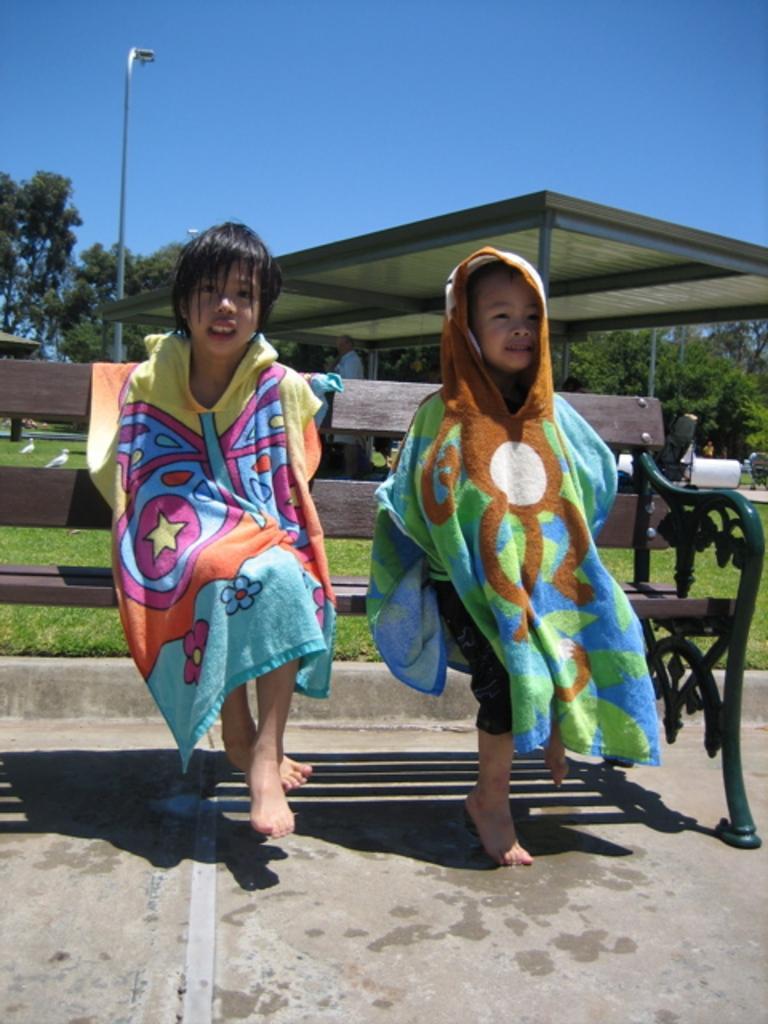Please provide a concise description of this image. In this picture there are two kids sitting on a bench and wore clothes and we can see birds, shed, grass, light pole, person, trees and objects. In the background of the image we can see the sky in blue color. 